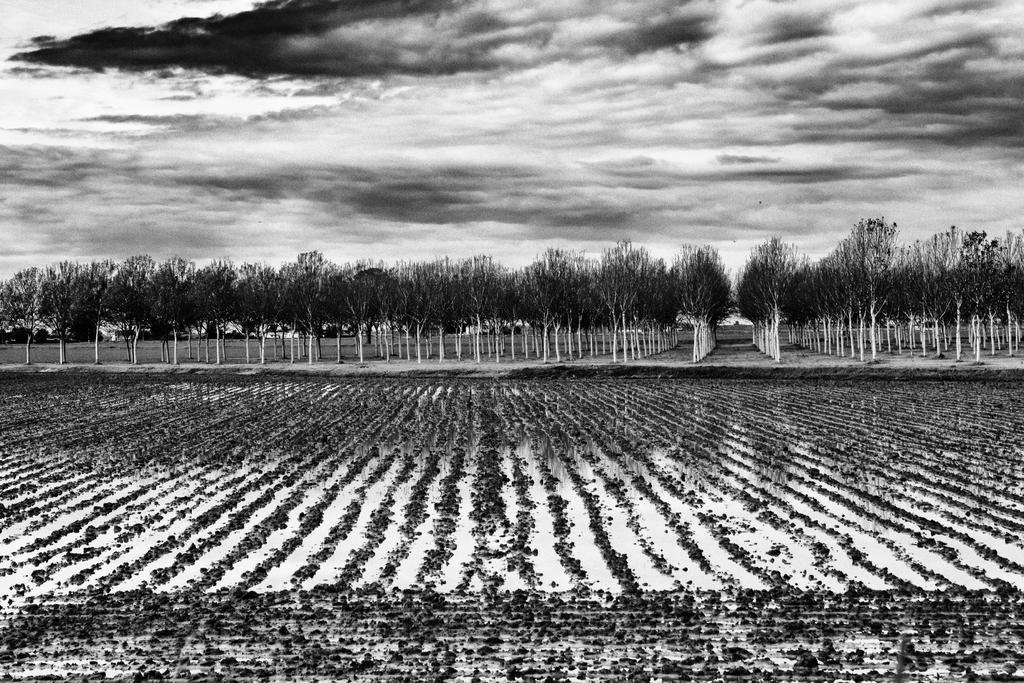What type of landscape is depicted in the image? There is a field in the image. What can be seen in the background of the field? There are plenty of trees behind the field in the image. What type of bell can be heard ringing in the image? There is no bell present in the image, and therefore no sound can be heard. 